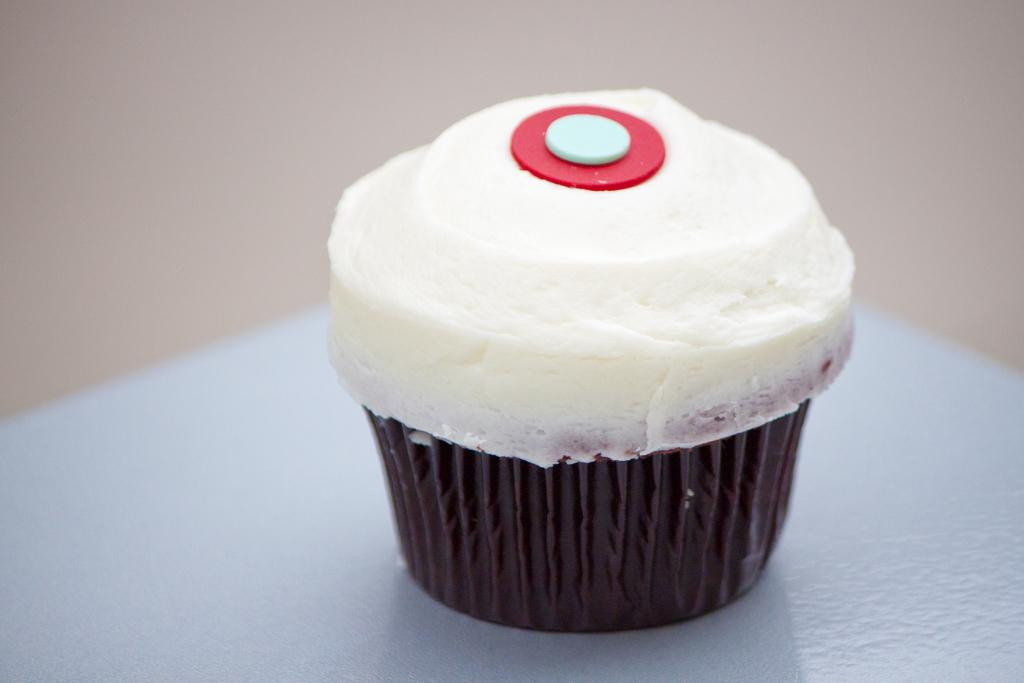What is the main subject in the foreground of the image? There is a cupcake in the foreground of the image. What color is the background of the image? The background of the image is cream-colored. What color is the background at the bottom of the image? There is a white background at the bottom of the image. What type of apparel is being worn by the cupcake in the image? There is no apparel present in the image, as the main subject is a cupcake. 